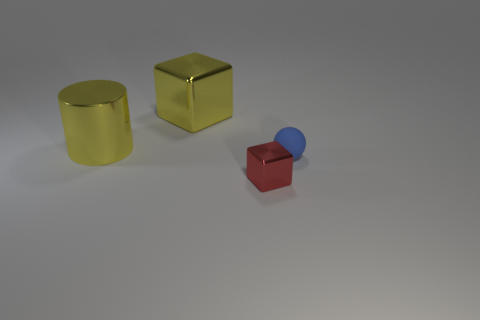Add 2 brown metallic things. How many objects exist? 6 Subtract all balls. How many objects are left? 3 Add 1 purple rubber objects. How many purple rubber objects exist? 1 Subtract 1 blue spheres. How many objects are left? 3 Subtract all small metal cubes. Subtract all matte objects. How many objects are left? 2 Add 2 tiny red metallic objects. How many tiny red metallic objects are left? 3 